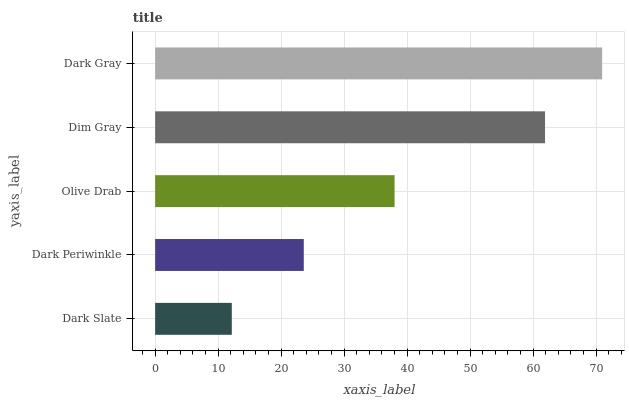Is Dark Slate the minimum?
Answer yes or no. Yes. Is Dark Gray the maximum?
Answer yes or no. Yes. Is Dark Periwinkle the minimum?
Answer yes or no. No. Is Dark Periwinkle the maximum?
Answer yes or no. No. Is Dark Periwinkle greater than Dark Slate?
Answer yes or no. Yes. Is Dark Slate less than Dark Periwinkle?
Answer yes or no. Yes. Is Dark Slate greater than Dark Periwinkle?
Answer yes or no. No. Is Dark Periwinkle less than Dark Slate?
Answer yes or no. No. Is Olive Drab the high median?
Answer yes or no. Yes. Is Olive Drab the low median?
Answer yes or no. Yes. Is Dim Gray the high median?
Answer yes or no. No. Is Dark Slate the low median?
Answer yes or no. No. 